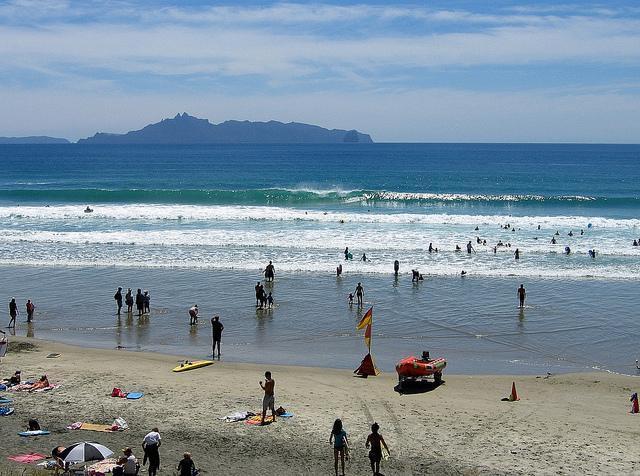How many umbrellas are in this photo?
Give a very brief answer. 1. 